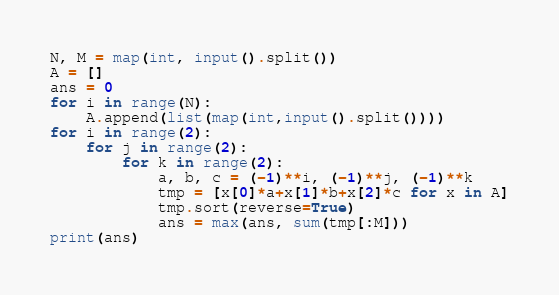Convert code to text. <code><loc_0><loc_0><loc_500><loc_500><_Python_>N, M = map(int, input().split())
A = []
ans = 0
for i in range(N):
    A.append(list(map(int,input().split())))
for i in range(2):
    for j in range(2):
        for k in range(2):
            a, b, c = (-1)**i, (-1)**j, (-1)**k
            tmp = [x[0]*a+x[1]*b+x[2]*c for x in A]
            tmp.sort(reverse=True)
            ans = max(ans, sum(tmp[:M]))
print(ans)</code> 